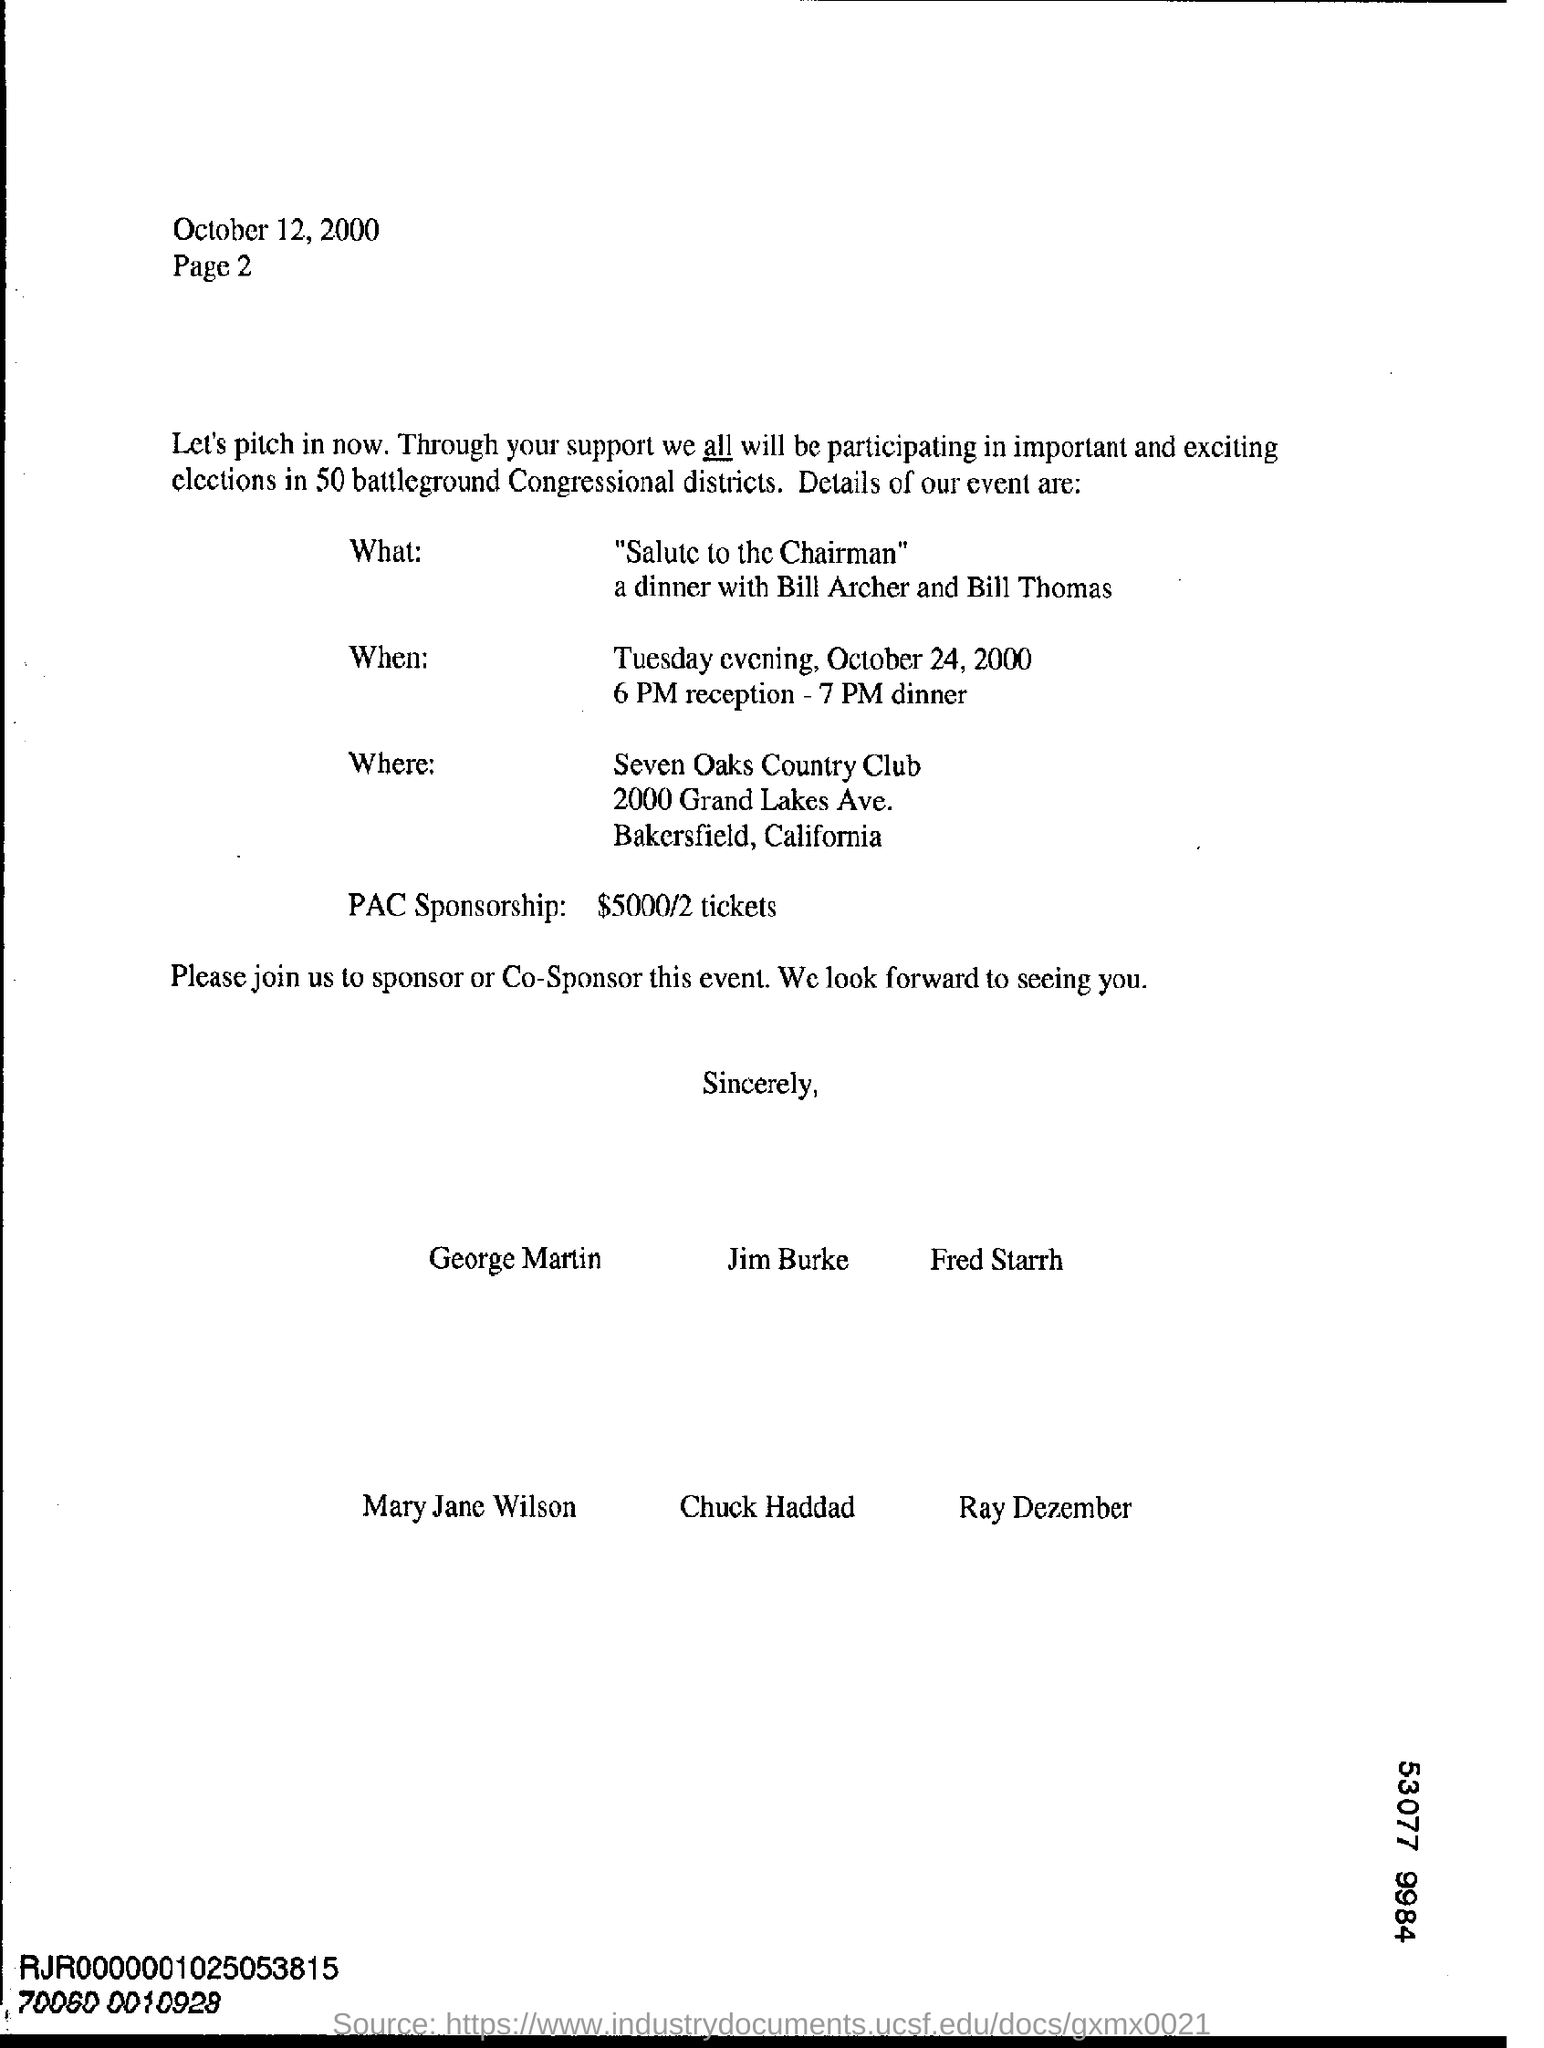What is the date on which this letter was sent?
Your response must be concise. October 12,2000. What is the name of the event?
Provide a succinct answer. "salute to the chairman". When is the event scheduled on?
Ensure brevity in your answer.  Tuesday evening, October 24,2000. At what time dinner is scheduled?
Your response must be concise. 7 pm. What is the name of the country club where the event is held?
Keep it short and to the point. Seven oaks country Club. What is the PAC sponsorship given in the letter?
Your answer should be compact. $ 5000/2 tickets. 